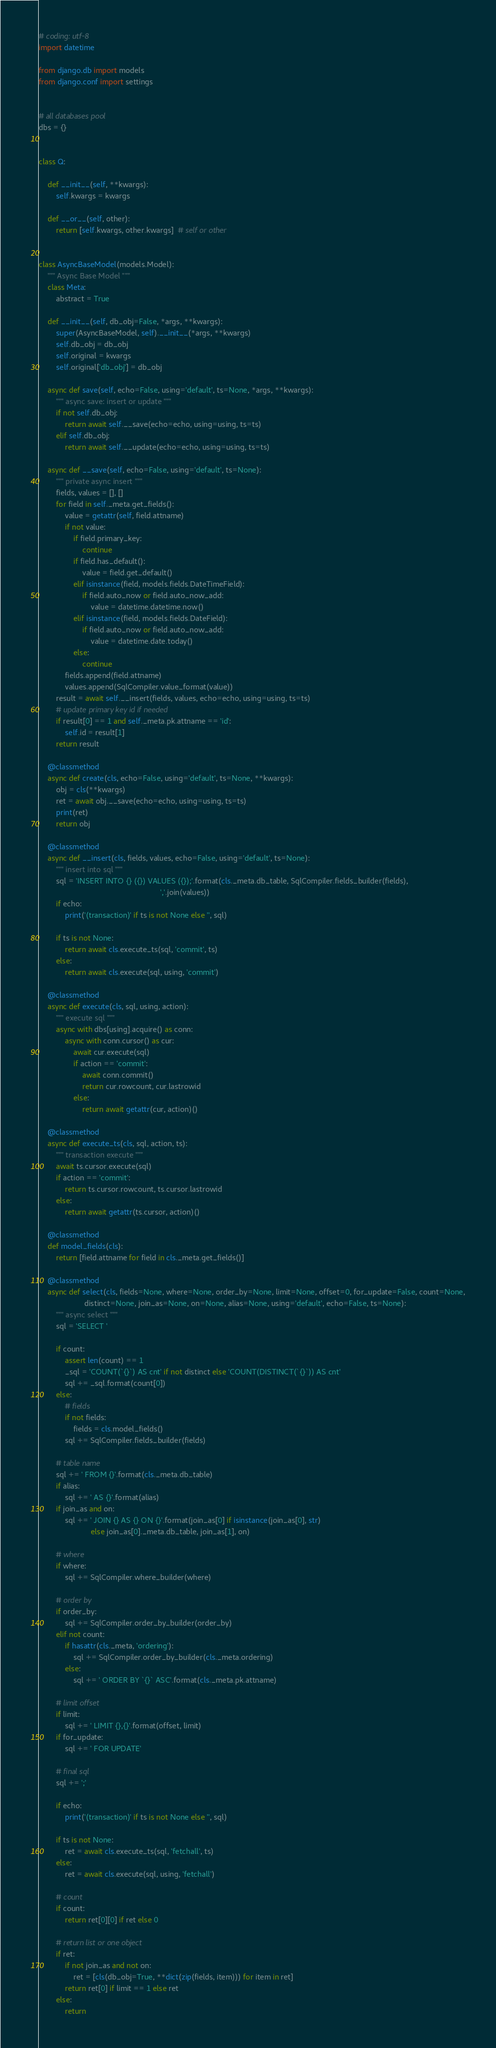Convert code to text. <code><loc_0><loc_0><loc_500><loc_500><_Python_># coding: utf-8
import datetime

from django.db import models
from django.conf import settings


# all databases pool
dbs = {}


class Q:

    def __init__(self, **kwargs):
        self.kwargs = kwargs

    def __or__(self, other):
        return [self.kwargs, other.kwargs]  # self or other


class AsyncBaseModel(models.Model):
    """ Async Base Model """
    class Meta:
        abstract = True

    def __init__(self, db_obj=False, *args, **kwargs):
        super(AsyncBaseModel, self).__init__(*args, **kwargs)
        self.db_obj = db_obj
        self.original = kwargs
        self.original['db_obj'] = db_obj

    async def save(self, echo=False, using='default', ts=None, *args, **kwargs):
        """ async save: insert or update """
        if not self.db_obj:
            return await self.__save(echo=echo, using=using, ts=ts)
        elif self.db_obj:
            return await self.__update(echo=echo, using=using, ts=ts)

    async def __save(self, echo=False, using='default', ts=None):
        """ private async insert """
        fields, values = [], []
        for field in self._meta.get_fields():
            value = getattr(self, field.attname)
            if not value:
                if field.primary_key:
                    continue
                if field.has_default():
                    value = field.get_default()
                elif isinstance(field, models.fields.DateTimeField):
                    if field.auto_now or field.auto_now_add:
                        value = datetime.datetime.now()
                elif isinstance(field, models.fields.DateField):
                    if field.auto_now or field.auto_now_add:
                        value = datetime.date.today()
                else:
                    continue
            fields.append(field.attname)
            values.append(SqlCompiler.value_format(value))
        result = await self.__insert(fields, values, echo=echo, using=using, ts=ts)
        # update primary key id if needed
        if result[0] == 1 and self._meta.pk.attname == 'id':
            self.id = result[1]
        return result

    @classmethod
    async def create(cls, echo=False, using='default', ts=None, **kwargs):
        obj = cls(**kwargs)
        ret = await obj.__save(echo=echo, using=using, ts=ts)
        print(ret)
        return obj

    @classmethod
    async def __insert(cls, fields, values, echo=False, using='default', ts=None):
        """ insert into sql """
        sql = 'INSERT INTO {} ({}) VALUES ({});'.format(cls._meta.db_table, SqlCompiler.fields_builder(fields),
                                                        ','.join(values))
        if echo:
            print('(transaction)' if ts is not None else '', sql)

        if ts is not None:
            return await cls.execute_ts(sql, 'commit', ts)
        else:
            return await cls.execute(sql, using, 'commit')

    @classmethod
    async def execute(cls, sql, using, action):
        """ execute sql """
        async with dbs[using].acquire() as conn:
            async with conn.cursor() as cur:
                await cur.execute(sql)
                if action == 'commit':
                    await conn.commit()
                    return cur.rowcount, cur.lastrowid
                else:
                    return await getattr(cur, action)()

    @classmethod
    async def execute_ts(cls, sql, action, ts):
        """ transaction execute """
        await ts.cursor.execute(sql)
        if action == 'commit':
            return ts.cursor.rowcount, ts.cursor.lastrowid
        else:
            return await getattr(ts.cursor, action)()

    @classmethod
    def model_fields(cls):
        return [field.attname for field in cls._meta.get_fields()]

    @classmethod
    async def select(cls, fields=None, where=None, order_by=None, limit=None, offset=0, for_update=False, count=None,
                     distinct=None, join_as=None, on=None, alias=None, using='default', echo=False, ts=None):
        """ async select """
        sql = 'SELECT '

        if count:
            assert len(count) == 1
            _sql = 'COUNT(`{}`) AS cnt' if not distinct else 'COUNT(DISTINCT(`{}`)) AS cnt'
            sql += _sql.format(count[0])
        else:
            # fields
            if not fields:
                fields = cls.model_fields()
            sql += SqlCompiler.fields_builder(fields)

        # table name
        sql += ' FROM {}'.format(cls._meta.db_table)
        if alias:
            sql += ' AS {}'.format(alias)
        if join_as and on:
            sql += ' JOIN {} AS {} ON {}'.format(join_as[0] if isinstance(join_as[0], str)
                        else join_as[0]._meta.db_table, join_as[1], on)

        # where
        if where:
            sql += SqlCompiler.where_builder(where)

        # order by
        if order_by:
            sql += SqlCompiler.order_by_builder(order_by)
        elif not count:
            if hasattr(cls._meta, 'ordering'):
                sql += SqlCompiler.order_by_builder(cls._meta.ordering)
            else:
                sql += ' ORDER BY `{}` ASC'.format(cls._meta.pk.attname)

        # limit offset
        if limit:
            sql += ' LIMIT {},{}'.format(offset, limit)
        if for_update:
            sql += ' FOR UPDATE'

        # final sql
        sql += ';'

        if echo:
            print('(transaction)' if ts is not None else '', sql)

        if ts is not None:
            ret = await cls.execute_ts(sql, 'fetchall', ts)
        else:
            ret = await cls.execute(sql, using, 'fetchall')

        # count
        if count:
            return ret[0][0] if ret else 0

        # return list or one object
        if ret:
            if not join_as and not on:
                ret = [cls(db_obj=True, **dict(zip(fields, item))) for item in ret]
            return ret[0] if limit == 1 else ret
        else:
            return
</code> 